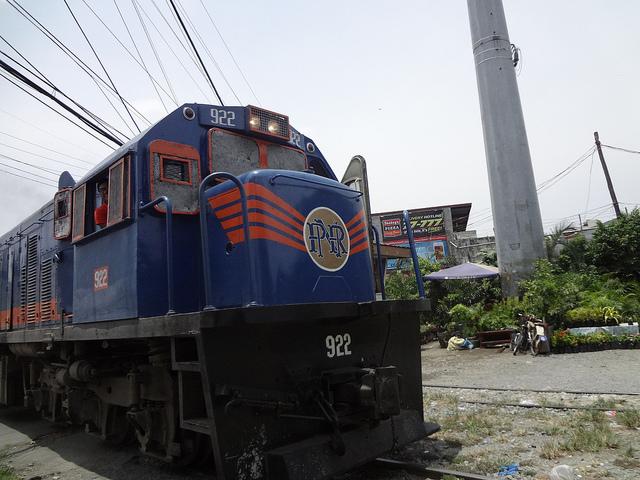Is someone visible?
Give a very brief answer. Yes. Is this an antique?
Answer briefly. No. What color is the train?
Concise answer only. Blue. What is the train number?
Quick response, please. 922. 